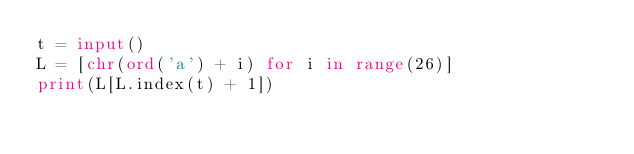<code> <loc_0><loc_0><loc_500><loc_500><_Python_>t = input()
L = [chr(ord('a') + i) for i in range(26)]
print(L[L.index(t) + 1])</code> 